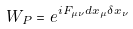Convert formula to latex. <formula><loc_0><loc_0><loc_500><loc_500>W _ { P } = e ^ { i F _ { \mu \nu } d x _ { \mu } \delta x _ { \nu } }</formula> 